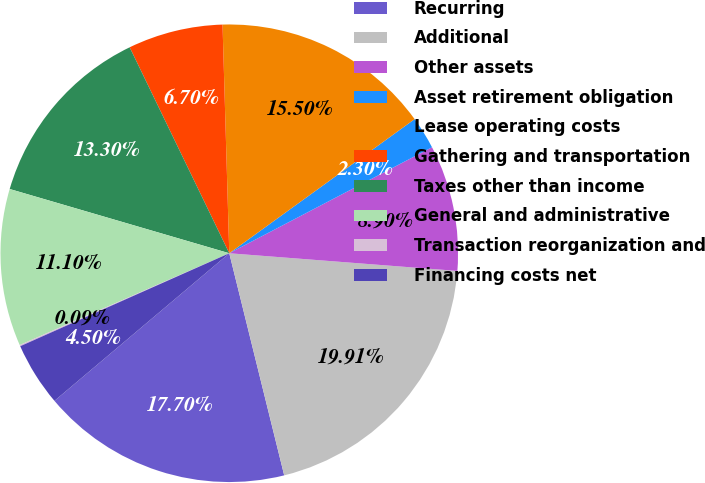<chart> <loc_0><loc_0><loc_500><loc_500><pie_chart><fcel>Recurring<fcel>Additional<fcel>Other assets<fcel>Asset retirement obligation<fcel>Lease operating costs<fcel>Gathering and transportation<fcel>Taxes other than income<fcel>General and administrative<fcel>Transaction reorganization and<fcel>Financing costs net<nl><fcel>17.7%<fcel>19.91%<fcel>8.9%<fcel>2.3%<fcel>15.5%<fcel>6.7%<fcel>13.3%<fcel>11.1%<fcel>0.09%<fcel>4.5%<nl></chart> 